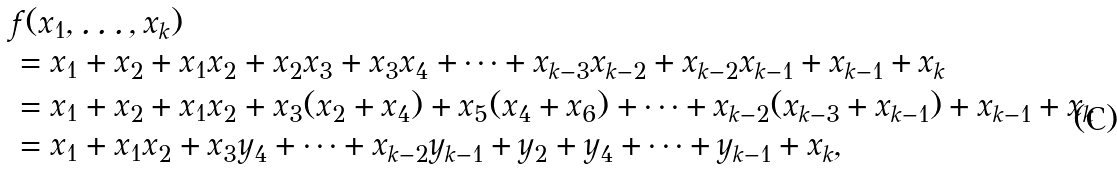Convert formula to latex. <formula><loc_0><loc_0><loc_500><loc_500>& f ( x _ { 1 } , \dots , x _ { k } ) \\ & = x _ { 1 } + x _ { 2 } + x _ { 1 } x _ { 2 } + x _ { 2 } x _ { 3 } + x _ { 3 } x _ { 4 } + \cdots + x _ { k - 3 } x _ { k - 2 } + x _ { k - 2 } x _ { k - 1 } + x _ { k - 1 } + x _ { k } \\ & = x _ { 1 } + x _ { 2 } + x _ { 1 } x _ { 2 } + x _ { 3 } ( x _ { 2 } + x _ { 4 } ) + x _ { 5 } ( x _ { 4 } + x _ { 6 } ) + \cdots + x _ { k - 2 } ( x _ { k - 3 } + x _ { k - 1 } ) + x _ { k - 1 } + x _ { k } \\ & = x _ { 1 } + x _ { 1 } x _ { 2 } + x _ { 3 } y _ { 4 } + \cdots + x _ { k - 2 } y _ { k - 1 } + y _ { 2 } + y _ { 4 } + \cdots + y _ { k - 1 } + x _ { k } ,</formula> 